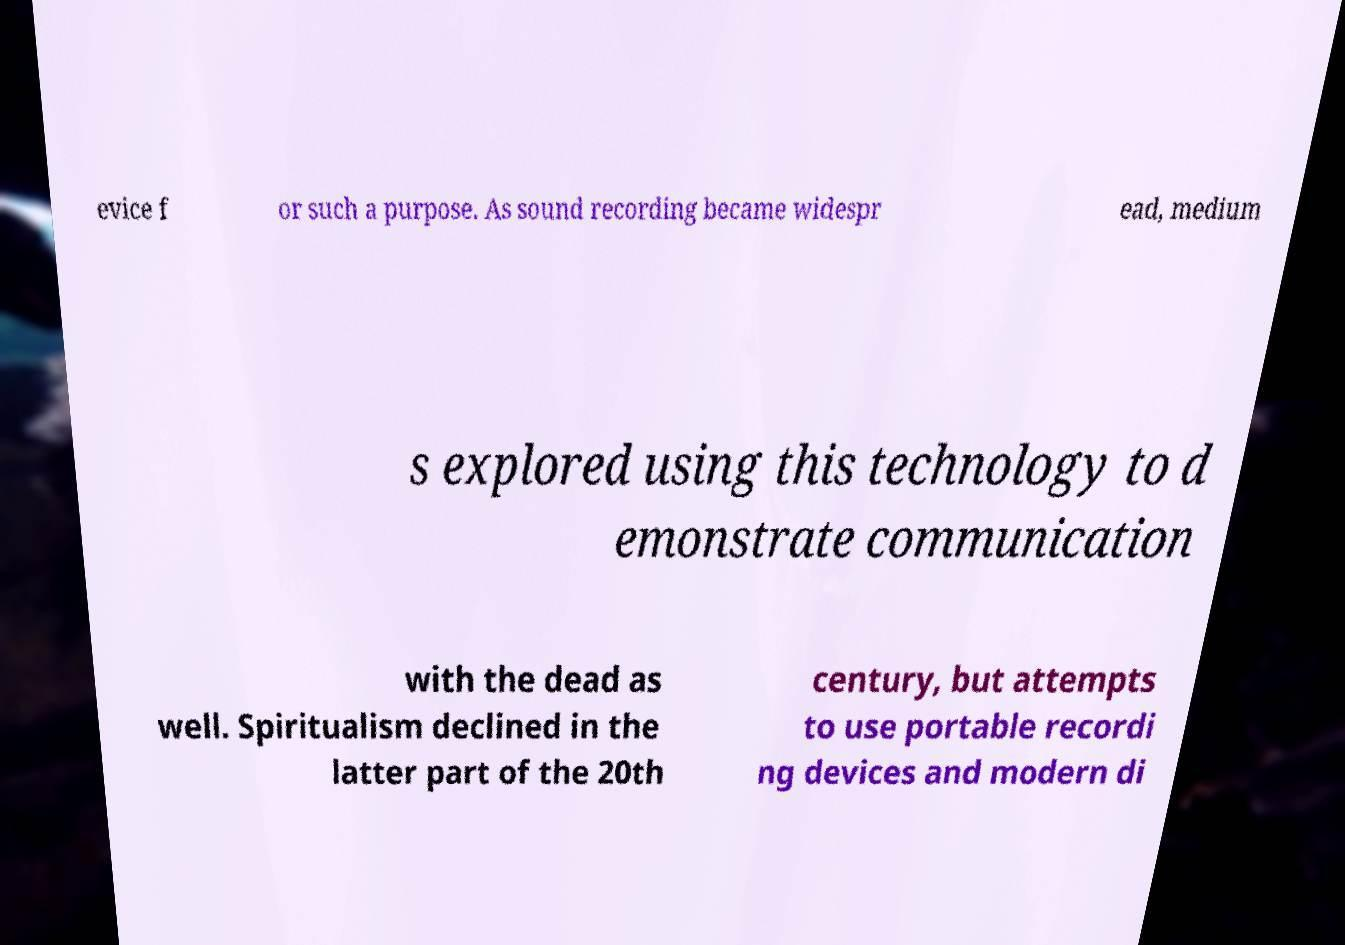Can you accurately transcribe the text from the provided image for me? evice f or such a purpose. As sound recording became widespr ead, medium s explored using this technology to d emonstrate communication with the dead as well. Spiritualism declined in the latter part of the 20th century, but attempts to use portable recordi ng devices and modern di 